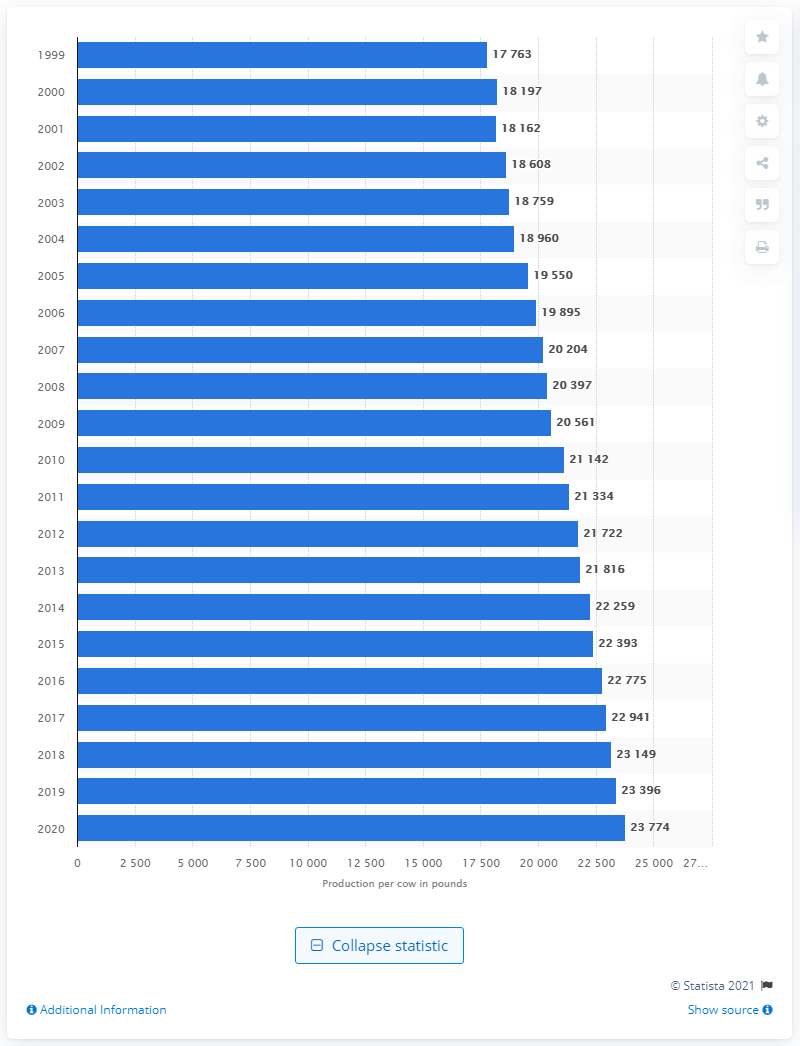Highlight a few significant elements in this photo. By 2020, it is projected that the average amount of milk produced per cow in the United States will be approximately 23,774 liters. In 1999, the average amount of milk produced per cow in the United States was approximately 17,763 pounds. 